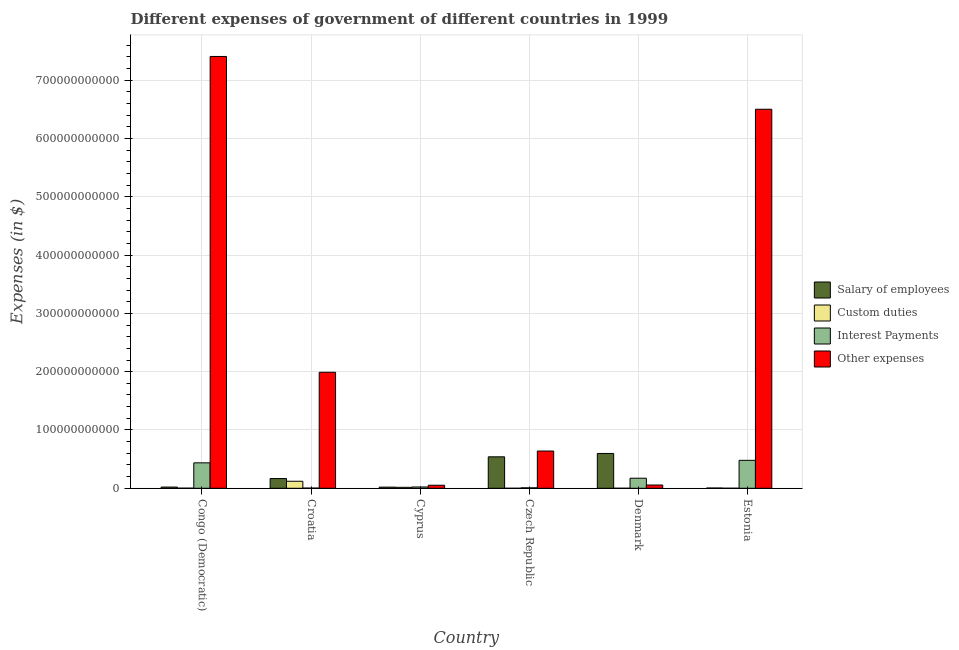How many groups of bars are there?
Your answer should be compact. 6. Are the number of bars on each tick of the X-axis equal?
Provide a short and direct response. No. How many bars are there on the 4th tick from the right?
Provide a short and direct response. 4. What is the label of the 4th group of bars from the left?
Give a very brief answer. Czech Republic. What is the amount spent on custom duties in Cyprus?
Provide a succinct answer. 1.66e+09. Across all countries, what is the maximum amount spent on interest payments?
Offer a very short reply. 4.79e+1. In which country was the amount spent on other expenses maximum?
Offer a terse response. Congo (Democratic). What is the total amount spent on salary of employees in the graph?
Provide a short and direct response. 1.35e+11. What is the difference between the amount spent on other expenses in Denmark and that in Estonia?
Your response must be concise. -6.44e+11. What is the difference between the amount spent on salary of employees in Congo (Democratic) and the amount spent on interest payments in Czech Republic?
Offer a terse response. 1.28e+09. What is the average amount spent on other expenses per country?
Ensure brevity in your answer.  2.77e+11. What is the difference between the amount spent on interest payments and amount spent on salary of employees in Denmark?
Offer a very short reply. -4.24e+1. In how many countries, is the amount spent on salary of employees greater than 300000000000 $?
Give a very brief answer. 0. What is the ratio of the amount spent on salary of employees in Denmark to that in Estonia?
Provide a succinct answer. 133.68. Is the amount spent on interest payments in Cyprus less than that in Estonia?
Offer a very short reply. Yes. Is the difference between the amount spent on custom duties in Croatia and Estonia greater than the difference between the amount spent on other expenses in Croatia and Estonia?
Give a very brief answer. Yes. What is the difference between the highest and the second highest amount spent on custom duties?
Your answer should be very brief. 1.04e+1. What is the difference between the highest and the lowest amount spent on custom duties?
Your answer should be compact. 1.20e+1. Is it the case that in every country, the sum of the amount spent on salary of employees and amount spent on custom duties is greater than the amount spent on interest payments?
Your response must be concise. No. Are all the bars in the graph horizontal?
Offer a very short reply. No. How many countries are there in the graph?
Give a very brief answer. 6. What is the difference between two consecutive major ticks on the Y-axis?
Provide a succinct answer. 1.00e+11. Are the values on the major ticks of Y-axis written in scientific E-notation?
Your response must be concise. No. Does the graph contain any zero values?
Give a very brief answer. Yes. Does the graph contain grids?
Give a very brief answer. Yes. Where does the legend appear in the graph?
Provide a succinct answer. Center right. How are the legend labels stacked?
Your answer should be very brief. Vertical. What is the title of the graph?
Offer a terse response. Different expenses of government of different countries in 1999. Does "Macroeconomic management" appear as one of the legend labels in the graph?
Keep it short and to the point. No. What is the label or title of the Y-axis?
Offer a very short reply. Expenses (in $). What is the Expenses (in $) in Salary of employees in Congo (Democratic)?
Make the answer very short. 2.08e+09. What is the Expenses (in $) in Custom duties in Congo (Democratic)?
Give a very brief answer. 1.75e+08. What is the Expenses (in $) of Interest Payments in Congo (Democratic)?
Your response must be concise. 4.36e+1. What is the Expenses (in $) of Other expenses in Congo (Democratic)?
Offer a terse response. 7.41e+11. What is the Expenses (in $) in Salary of employees in Croatia?
Your response must be concise. 1.67e+1. What is the Expenses (in $) of Custom duties in Croatia?
Give a very brief answer. 1.20e+1. What is the Expenses (in $) in Interest Payments in Croatia?
Give a very brief answer. 2.96e+08. What is the Expenses (in $) of Other expenses in Croatia?
Ensure brevity in your answer.  1.99e+11. What is the Expenses (in $) of Salary of employees in Cyprus?
Your response must be concise. 1.98e+09. What is the Expenses (in $) of Custom duties in Cyprus?
Keep it short and to the point. 1.66e+09. What is the Expenses (in $) in Interest Payments in Cyprus?
Provide a short and direct response. 2.23e+09. What is the Expenses (in $) of Other expenses in Cyprus?
Make the answer very short. 5.24e+09. What is the Expenses (in $) of Salary of employees in Czech Republic?
Your response must be concise. 5.40e+1. What is the Expenses (in $) in Custom duties in Czech Republic?
Make the answer very short. 0. What is the Expenses (in $) in Interest Payments in Czech Republic?
Give a very brief answer. 7.99e+08. What is the Expenses (in $) in Other expenses in Czech Republic?
Ensure brevity in your answer.  6.39e+1. What is the Expenses (in $) in Salary of employees in Denmark?
Your answer should be very brief. 5.97e+1. What is the Expenses (in $) in Custom duties in Denmark?
Offer a very short reply. 2.40e+07. What is the Expenses (in $) of Interest Payments in Denmark?
Your response must be concise. 1.73e+1. What is the Expenses (in $) in Other expenses in Denmark?
Give a very brief answer. 5.61e+09. What is the Expenses (in $) in Salary of employees in Estonia?
Make the answer very short. 4.47e+08. What is the Expenses (in $) in Custom duties in Estonia?
Make the answer very short. 2.60e+07. What is the Expenses (in $) in Interest Payments in Estonia?
Provide a succinct answer. 4.79e+1. What is the Expenses (in $) of Other expenses in Estonia?
Provide a short and direct response. 6.50e+11. Across all countries, what is the maximum Expenses (in $) in Salary of employees?
Your answer should be compact. 5.97e+1. Across all countries, what is the maximum Expenses (in $) in Custom duties?
Offer a very short reply. 1.20e+1. Across all countries, what is the maximum Expenses (in $) of Interest Payments?
Give a very brief answer. 4.79e+1. Across all countries, what is the maximum Expenses (in $) in Other expenses?
Provide a short and direct response. 7.41e+11. Across all countries, what is the minimum Expenses (in $) in Salary of employees?
Provide a short and direct response. 4.47e+08. Across all countries, what is the minimum Expenses (in $) in Custom duties?
Make the answer very short. 0. Across all countries, what is the minimum Expenses (in $) of Interest Payments?
Provide a succinct answer. 2.96e+08. Across all countries, what is the minimum Expenses (in $) in Other expenses?
Offer a terse response. 5.24e+09. What is the total Expenses (in $) of Salary of employees in the graph?
Ensure brevity in your answer.  1.35e+11. What is the total Expenses (in $) in Custom duties in the graph?
Give a very brief answer. 1.39e+1. What is the total Expenses (in $) in Interest Payments in the graph?
Offer a very short reply. 1.12e+11. What is the total Expenses (in $) in Other expenses in the graph?
Offer a terse response. 1.66e+12. What is the difference between the Expenses (in $) in Salary of employees in Congo (Democratic) and that in Croatia?
Your answer should be very brief. -1.46e+1. What is the difference between the Expenses (in $) of Custom duties in Congo (Democratic) and that in Croatia?
Your answer should be very brief. -1.19e+1. What is the difference between the Expenses (in $) in Interest Payments in Congo (Democratic) and that in Croatia?
Provide a short and direct response. 4.33e+1. What is the difference between the Expenses (in $) of Other expenses in Congo (Democratic) and that in Croatia?
Your answer should be very brief. 5.42e+11. What is the difference between the Expenses (in $) in Salary of employees in Congo (Democratic) and that in Cyprus?
Your answer should be very brief. 9.89e+07. What is the difference between the Expenses (in $) of Custom duties in Congo (Democratic) and that in Cyprus?
Give a very brief answer. -1.48e+09. What is the difference between the Expenses (in $) of Interest Payments in Congo (Democratic) and that in Cyprus?
Give a very brief answer. 4.14e+1. What is the difference between the Expenses (in $) in Other expenses in Congo (Democratic) and that in Cyprus?
Offer a very short reply. 7.35e+11. What is the difference between the Expenses (in $) in Salary of employees in Congo (Democratic) and that in Czech Republic?
Your answer should be very brief. -5.19e+1. What is the difference between the Expenses (in $) of Interest Payments in Congo (Democratic) and that in Czech Republic?
Your answer should be compact. 4.28e+1. What is the difference between the Expenses (in $) of Other expenses in Congo (Democratic) and that in Czech Republic?
Provide a short and direct response. 6.77e+11. What is the difference between the Expenses (in $) of Salary of employees in Congo (Democratic) and that in Denmark?
Keep it short and to the point. -5.76e+1. What is the difference between the Expenses (in $) in Custom duties in Congo (Democratic) and that in Denmark?
Your response must be concise. 1.51e+08. What is the difference between the Expenses (in $) of Interest Payments in Congo (Democratic) and that in Denmark?
Ensure brevity in your answer.  2.64e+1. What is the difference between the Expenses (in $) in Other expenses in Congo (Democratic) and that in Denmark?
Offer a very short reply. 7.35e+11. What is the difference between the Expenses (in $) in Salary of employees in Congo (Democratic) and that in Estonia?
Provide a succinct answer. 1.63e+09. What is the difference between the Expenses (in $) of Custom duties in Congo (Democratic) and that in Estonia?
Your answer should be compact. 1.49e+08. What is the difference between the Expenses (in $) in Interest Payments in Congo (Democratic) and that in Estonia?
Ensure brevity in your answer.  -4.29e+09. What is the difference between the Expenses (in $) in Other expenses in Congo (Democratic) and that in Estonia?
Offer a very short reply. 9.05e+1. What is the difference between the Expenses (in $) in Salary of employees in Croatia and that in Cyprus?
Make the answer very short. 1.47e+1. What is the difference between the Expenses (in $) in Custom duties in Croatia and that in Cyprus?
Keep it short and to the point. 1.04e+1. What is the difference between the Expenses (in $) in Interest Payments in Croatia and that in Cyprus?
Your response must be concise. -1.93e+09. What is the difference between the Expenses (in $) of Other expenses in Croatia and that in Cyprus?
Keep it short and to the point. 1.94e+11. What is the difference between the Expenses (in $) in Salary of employees in Croatia and that in Czech Republic?
Offer a terse response. -3.73e+1. What is the difference between the Expenses (in $) in Interest Payments in Croatia and that in Czech Republic?
Your answer should be compact. -5.03e+08. What is the difference between the Expenses (in $) of Other expenses in Croatia and that in Czech Republic?
Offer a terse response. 1.35e+11. What is the difference between the Expenses (in $) of Salary of employees in Croatia and that in Denmark?
Your response must be concise. -4.30e+1. What is the difference between the Expenses (in $) of Custom duties in Croatia and that in Denmark?
Provide a short and direct response. 1.20e+1. What is the difference between the Expenses (in $) in Interest Payments in Croatia and that in Denmark?
Your answer should be very brief. -1.70e+1. What is the difference between the Expenses (in $) of Other expenses in Croatia and that in Denmark?
Keep it short and to the point. 1.93e+11. What is the difference between the Expenses (in $) in Salary of employees in Croatia and that in Estonia?
Give a very brief answer. 1.62e+1. What is the difference between the Expenses (in $) in Custom duties in Croatia and that in Estonia?
Your answer should be compact. 1.20e+1. What is the difference between the Expenses (in $) of Interest Payments in Croatia and that in Estonia?
Offer a terse response. -4.76e+1. What is the difference between the Expenses (in $) in Other expenses in Croatia and that in Estonia?
Keep it short and to the point. -4.51e+11. What is the difference between the Expenses (in $) of Salary of employees in Cyprus and that in Czech Republic?
Offer a very short reply. -5.20e+1. What is the difference between the Expenses (in $) in Interest Payments in Cyprus and that in Czech Republic?
Offer a very short reply. 1.43e+09. What is the difference between the Expenses (in $) of Other expenses in Cyprus and that in Czech Republic?
Offer a terse response. -5.87e+1. What is the difference between the Expenses (in $) in Salary of employees in Cyprus and that in Denmark?
Your response must be concise. -5.77e+1. What is the difference between the Expenses (in $) in Custom duties in Cyprus and that in Denmark?
Offer a very short reply. 1.63e+09. What is the difference between the Expenses (in $) in Interest Payments in Cyprus and that in Denmark?
Ensure brevity in your answer.  -1.50e+1. What is the difference between the Expenses (in $) of Other expenses in Cyprus and that in Denmark?
Your answer should be very brief. -3.71e+08. What is the difference between the Expenses (in $) of Salary of employees in Cyprus and that in Estonia?
Provide a short and direct response. 1.53e+09. What is the difference between the Expenses (in $) of Custom duties in Cyprus and that in Estonia?
Your answer should be very brief. 1.63e+09. What is the difference between the Expenses (in $) in Interest Payments in Cyprus and that in Estonia?
Offer a terse response. -4.57e+1. What is the difference between the Expenses (in $) in Other expenses in Cyprus and that in Estonia?
Make the answer very short. -6.45e+11. What is the difference between the Expenses (in $) of Salary of employees in Czech Republic and that in Denmark?
Make the answer very short. -5.74e+09. What is the difference between the Expenses (in $) in Interest Payments in Czech Republic and that in Denmark?
Your response must be concise. -1.65e+1. What is the difference between the Expenses (in $) of Other expenses in Czech Republic and that in Denmark?
Ensure brevity in your answer.  5.83e+1. What is the difference between the Expenses (in $) in Salary of employees in Czech Republic and that in Estonia?
Ensure brevity in your answer.  5.35e+1. What is the difference between the Expenses (in $) in Interest Payments in Czech Republic and that in Estonia?
Your response must be concise. -4.71e+1. What is the difference between the Expenses (in $) of Other expenses in Czech Republic and that in Estonia?
Ensure brevity in your answer.  -5.86e+11. What is the difference between the Expenses (in $) of Salary of employees in Denmark and that in Estonia?
Ensure brevity in your answer.  5.93e+1. What is the difference between the Expenses (in $) of Custom duties in Denmark and that in Estonia?
Provide a succinct answer. -2.00e+06. What is the difference between the Expenses (in $) of Interest Payments in Denmark and that in Estonia?
Give a very brief answer. -3.06e+1. What is the difference between the Expenses (in $) of Other expenses in Denmark and that in Estonia?
Provide a succinct answer. -6.44e+11. What is the difference between the Expenses (in $) in Salary of employees in Congo (Democratic) and the Expenses (in $) in Custom duties in Croatia?
Keep it short and to the point. -9.97e+09. What is the difference between the Expenses (in $) in Salary of employees in Congo (Democratic) and the Expenses (in $) in Interest Payments in Croatia?
Make the answer very short. 1.78e+09. What is the difference between the Expenses (in $) of Salary of employees in Congo (Democratic) and the Expenses (in $) of Other expenses in Croatia?
Provide a short and direct response. -1.97e+11. What is the difference between the Expenses (in $) in Custom duties in Congo (Democratic) and the Expenses (in $) in Interest Payments in Croatia?
Offer a terse response. -1.21e+08. What is the difference between the Expenses (in $) of Custom duties in Congo (Democratic) and the Expenses (in $) of Other expenses in Croatia?
Your response must be concise. -1.99e+11. What is the difference between the Expenses (in $) of Interest Payments in Congo (Democratic) and the Expenses (in $) of Other expenses in Croatia?
Your response must be concise. -1.55e+11. What is the difference between the Expenses (in $) of Salary of employees in Congo (Democratic) and the Expenses (in $) of Custom duties in Cyprus?
Your answer should be compact. 4.25e+08. What is the difference between the Expenses (in $) of Salary of employees in Congo (Democratic) and the Expenses (in $) of Interest Payments in Cyprus?
Your response must be concise. -1.47e+08. What is the difference between the Expenses (in $) in Salary of employees in Congo (Democratic) and the Expenses (in $) in Other expenses in Cyprus?
Offer a very short reply. -3.16e+09. What is the difference between the Expenses (in $) of Custom duties in Congo (Democratic) and the Expenses (in $) of Interest Payments in Cyprus?
Offer a very short reply. -2.05e+09. What is the difference between the Expenses (in $) in Custom duties in Congo (Democratic) and the Expenses (in $) in Other expenses in Cyprus?
Your answer should be compact. -5.06e+09. What is the difference between the Expenses (in $) of Interest Payments in Congo (Democratic) and the Expenses (in $) of Other expenses in Cyprus?
Ensure brevity in your answer.  3.84e+1. What is the difference between the Expenses (in $) of Salary of employees in Congo (Democratic) and the Expenses (in $) of Interest Payments in Czech Republic?
Make the answer very short. 1.28e+09. What is the difference between the Expenses (in $) of Salary of employees in Congo (Democratic) and the Expenses (in $) of Other expenses in Czech Republic?
Your answer should be very brief. -6.18e+1. What is the difference between the Expenses (in $) of Custom duties in Congo (Democratic) and the Expenses (in $) of Interest Payments in Czech Republic?
Provide a short and direct response. -6.23e+08. What is the difference between the Expenses (in $) of Custom duties in Congo (Democratic) and the Expenses (in $) of Other expenses in Czech Republic?
Offer a very short reply. -6.37e+1. What is the difference between the Expenses (in $) in Interest Payments in Congo (Democratic) and the Expenses (in $) in Other expenses in Czech Republic?
Keep it short and to the point. -2.03e+1. What is the difference between the Expenses (in $) in Salary of employees in Congo (Democratic) and the Expenses (in $) in Custom duties in Denmark?
Ensure brevity in your answer.  2.06e+09. What is the difference between the Expenses (in $) in Salary of employees in Congo (Democratic) and the Expenses (in $) in Interest Payments in Denmark?
Offer a very short reply. -1.52e+1. What is the difference between the Expenses (in $) of Salary of employees in Congo (Democratic) and the Expenses (in $) of Other expenses in Denmark?
Make the answer very short. -3.53e+09. What is the difference between the Expenses (in $) in Custom duties in Congo (Democratic) and the Expenses (in $) in Interest Payments in Denmark?
Your response must be concise. -1.71e+1. What is the difference between the Expenses (in $) in Custom duties in Congo (Democratic) and the Expenses (in $) in Other expenses in Denmark?
Your answer should be very brief. -5.43e+09. What is the difference between the Expenses (in $) of Interest Payments in Congo (Democratic) and the Expenses (in $) of Other expenses in Denmark?
Provide a succinct answer. 3.80e+1. What is the difference between the Expenses (in $) in Salary of employees in Congo (Democratic) and the Expenses (in $) in Custom duties in Estonia?
Your answer should be very brief. 2.05e+09. What is the difference between the Expenses (in $) in Salary of employees in Congo (Democratic) and the Expenses (in $) in Interest Payments in Estonia?
Your answer should be compact. -4.58e+1. What is the difference between the Expenses (in $) in Salary of employees in Congo (Democratic) and the Expenses (in $) in Other expenses in Estonia?
Provide a short and direct response. -6.48e+11. What is the difference between the Expenses (in $) in Custom duties in Congo (Democratic) and the Expenses (in $) in Interest Payments in Estonia?
Offer a very short reply. -4.77e+1. What is the difference between the Expenses (in $) in Custom duties in Congo (Democratic) and the Expenses (in $) in Other expenses in Estonia?
Your answer should be compact. -6.50e+11. What is the difference between the Expenses (in $) of Interest Payments in Congo (Democratic) and the Expenses (in $) of Other expenses in Estonia?
Keep it short and to the point. -6.06e+11. What is the difference between the Expenses (in $) in Salary of employees in Croatia and the Expenses (in $) in Custom duties in Cyprus?
Give a very brief answer. 1.50e+1. What is the difference between the Expenses (in $) of Salary of employees in Croatia and the Expenses (in $) of Interest Payments in Cyprus?
Make the answer very short. 1.45e+1. What is the difference between the Expenses (in $) of Salary of employees in Croatia and the Expenses (in $) of Other expenses in Cyprus?
Your response must be concise. 1.14e+1. What is the difference between the Expenses (in $) in Custom duties in Croatia and the Expenses (in $) in Interest Payments in Cyprus?
Ensure brevity in your answer.  9.82e+09. What is the difference between the Expenses (in $) in Custom duties in Croatia and the Expenses (in $) in Other expenses in Cyprus?
Keep it short and to the point. 6.81e+09. What is the difference between the Expenses (in $) in Interest Payments in Croatia and the Expenses (in $) in Other expenses in Cyprus?
Your answer should be very brief. -4.94e+09. What is the difference between the Expenses (in $) in Salary of employees in Croatia and the Expenses (in $) in Interest Payments in Czech Republic?
Provide a succinct answer. 1.59e+1. What is the difference between the Expenses (in $) of Salary of employees in Croatia and the Expenses (in $) of Other expenses in Czech Republic?
Provide a succinct answer. -4.72e+1. What is the difference between the Expenses (in $) of Custom duties in Croatia and the Expenses (in $) of Interest Payments in Czech Republic?
Keep it short and to the point. 1.13e+1. What is the difference between the Expenses (in $) in Custom duties in Croatia and the Expenses (in $) in Other expenses in Czech Republic?
Offer a terse response. -5.18e+1. What is the difference between the Expenses (in $) of Interest Payments in Croatia and the Expenses (in $) of Other expenses in Czech Republic?
Offer a terse response. -6.36e+1. What is the difference between the Expenses (in $) in Salary of employees in Croatia and the Expenses (in $) in Custom duties in Denmark?
Give a very brief answer. 1.67e+1. What is the difference between the Expenses (in $) in Salary of employees in Croatia and the Expenses (in $) in Interest Payments in Denmark?
Ensure brevity in your answer.  -5.86e+08. What is the difference between the Expenses (in $) in Salary of employees in Croatia and the Expenses (in $) in Other expenses in Denmark?
Make the answer very short. 1.11e+1. What is the difference between the Expenses (in $) in Custom duties in Croatia and the Expenses (in $) in Interest Payments in Denmark?
Provide a succinct answer. -5.22e+09. What is the difference between the Expenses (in $) of Custom duties in Croatia and the Expenses (in $) of Other expenses in Denmark?
Keep it short and to the point. 6.44e+09. What is the difference between the Expenses (in $) in Interest Payments in Croatia and the Expenses (in $) in Other expenses in Denmark?
Provide a succinct answer. -5.31e+09. What is the difference between the Expenses (in $) of Salary of employees in Croatia and the Expenses (in $) of Custom duties in Estonia?
Keep it short and to the point. 1.67e+1. What is the difference between the Expenses (in $) in Salary of employees in Croatia and the Expenses (in $) in Interest Payments in Estonia?
Make the answer very short. -3.12e+1. What is the difference between the Expenses (in $) of Salary of employees in Croatia and the Expenses (in $) of Other expenses in Estonia?
Ensure brevity in your answer.  -6.33e+11. What is the difference between the Expenses (in $) of Custom duties in Croatia and the Expenses (in $) of Interest Payments in Estonia?
Give a very brief answer. -3.59e+1. What is the difference between the Expenses (in $) of Custom duties in Croatia and the Expenses (in $) of Other expenses in Estonia?
Your answer should be very brief. -6.38e+11. What is the difference between the Expenses (in $) of Interest Payments in Croatia and the Expenses (in $) of Other expenses in Estonia?
Give a very brief answer. -6.50e+11. What is the difference between the Expenses (in $) of Salary of employees in Cyprus and the Expenses (in $) of Interest Payments in Czech Republic?
Your answer should be compact. 1.18e+09. What is the difference between the Expenses (in $) in Salary of employees in Cyprus and the Expenses (in $) in Other expenses in Czech Republic?
Provide a short and direct response. -6.19e+1. What is the difference between the Expenses (in $) of Custom duties in Cyprus and the Expenses (in $) of Interest Payments in Czech Republic?
Your answer should be very brief. 8.57e+08. What is the difference between the Expenses (in $) of Custom duties in Cyprus and the Expenses (in $) of Other expenses in Czech Republic?
Provide a succinct answer. -6.22e+1. What is the difference between the Expenses (in $) of Interest Payments in Cyprus and the Expenses (in $) of Other expenses in Czech Republic?
Your response must be concise. -6.17e+1. What is the difference between the Expenses (in $) in Salary of employees in Cyprus and the Expenses (in $) in Custom duties in Denmark?
Ensure brevity in your answer.  1.96e+09. What is the difference between the Expenses (in $) of Salary of employees in Cyprus and the Expenses (in $) of Interest Payments in Denmark?
Provide a short and direct response. -1.53e+1. What is the difference between the Expenses (in $) of Salary of employees in Cyprus and the Expenses (in $) of Other expenses in Denmark?
Your answer should be very brief. -3.63e+09. What is the difference between the Expenses (in $) in Custom duties in Cyprus and the Expenses (in $) in Interest Payments in Denmark?
Keep it short and to the point. -1.56e+1. What is the difference between the Expenses (in $) of Custom duties in Cyprus and the Expenses (in $) of Other expenses in Denmark?
Give a very brief answer. -3.95e+09. What is the difference between the Expenses (in $) in Interest Payments in Cyprus and the Expenses (in $) in Other expenses in Denmark?
Provide a short and direct response. -3.38e+09. What is the difference between the Expenses (in $) in Salary of employees in Cyprus and the Expenses (in $) in Custom duties in Estonia?
Offer a very short reply. 1.96e+09. What is the difference between the Expenses (in $) of Salary of employees in Cyprus and the Expenses (in $) of Interest Payments in Estonia?
Your answer should be very brief. -4.59e+1. What is the difference between the Expenses (in $) of Salary of employees in Cyprus and the Expenses (in $) of Other expenses in Estonia?
Make the answer very short. -6.48e+11. What is the difference between the Expenses (in $) of Custom duties in Cyprus and the Expenses (in $) of Interest Payments in Estonia?
Your answer should be compact. -4.63e+1. What is the difference between the Expenses (in $) of Custom duties in Cyprus and the Expenses (in $) of Other expenses in Estonia?
Your answer should be very brief. -6.48e+11. What is the difference between the Expenses (in $) of Interest Payments in Cyprus and the Expenses (in $) of Other expenses in Estonia?
Offer a terse response. -6.48e+11. What is the difference between the Expenses (in $) of Salary of employees in Czech Republic and the Expenses (in $) of Custom duties in Denmark?
Offer a terse response. 5.39e+1. What is the difference between the Expenses (in $) in Salary of employees in Czech Republic and the Expenses (in $) in Interest Payments in Denmark?
Provide a succinct answer. 3.67e+1. What is the difference between the Expenses (in $) of Salary of employees in Czech Republic and the Expenses (in $) of Other expenses in Denmark?
Provide a short and direct response. 4.84e+1. What is the difference between the Expenses (in $) in Interest Payments in Czech Republic and the Expenses (in $) in Other expenses in Denmark?
Offer a very short reply. -4.81e+09. What is the difference between the Expenses (in $) of Salary of employees in Czech Republic and the Expenses (in $) of Custom duties in Estonia?
Keep it short and to the point. 5.39e+1. What is the difference between the Expenses (in $) in Salary of employees in Czech Republic and the Expenses (in $) in Interest Payments in Estonia?
Ensure brevity in your answer.  6.05e+09. What is the difference between the Expenses (in $) in Salary of employees in Czech Republic and the Expenses (in $) in Other expenses in Estonia?
Make the answer very short. -5.96e+11. What is the difference between the Expenses (in $) of Interest Payments in Czech Republic and the Expenses (in $) of Other expenses in Estonia?
Provide a short and direct response. -6.49e+11. What is the difference between the Expenses (in $) in Salary of employees in Denmark and the Expenses (in $) in Custom duties in Estonia?
Your answer should be compact. 5.97e+1. What is the difference between the Expenses (in $) of Salary of employees in Denmark and the Expenses (in $) of Interest Payments in Estonia?
Offer a terse response. 1.18e+1. What is the difference between the Expenses (in $) in Salary of employees in Denmark and the Expenses (in $) in Other expenses in Estonia?
Keep it short and to the point. -5.90e+11. What is the difference between the Expenses (in $) in Custom duties in Denmark and the Expenses (in $) in Interest Payments in Estonia?
Keep it short and to the point. -4.79e+1. What is the difference between the Expenses (in $) of Custom duties in Denmark and the Expenses (in $) of Other expenses in Estonia?
Ensure brevity in your answer.  -6.50e+11. What is the difference between the Expenses (in $) of Interest Payments in Denmark and the Expenses (in $) of Other expenses in Estonia?
Provide a short and direct response. -6.33e+11. What is the average Expenses (in $) of Salary of employees per country?
Make the answer very short. 2.25e+1. What is the average Expenses (in $) in Custom duties per country?
Ensure brevity in your answer.  2.32e+09. What is the average Expenses (in $) in Interest Payments per country?
Give a very brief answer. 1.87e+1. What is the average Expenses (in $) of Other expenses per country?
Your answer should be very brief. 2.77e+11. What is the difference between the Expenses (in $) in Salary of employees and Expenses (in $) in Custom duties in Congo (Democratic)?
Your answer should be compact. 1.90e+09. What is the difference between the Expenses (in $) of Salary of employees and Expenses (in $) of Interest Payments in Congo (Democratic)?
Your answer should be very brief. -4.16e+1. What is the difference between the Expenses (in $) of Salary of employees and Expenses (in $) of Other expenses in Congo (Democratic)?
Your answer should be compact. -7.39e+11. What is the difference between the Expenses (in $) in Custom duties and Expenses (in $) in Interest Payments in Congo (Democratic)?
Your response must be concise. -4.35e+1. What is the difference between the Expenses (in $) of Custom duties and Expenses (in $) of Other expenses in Congo (Democratic)?
Your answer should be very brief. -7.40e+11. What is the difference between the Expenses (in $) in Interest Payments and Expenses (in $) in Other expenses in Congo (Democratic)?
Give a very brief answer. -6.97e+11. What is the difference between the Expenses (in $) of Salary of employees and Expenses (in $) of Custom duties in Croatia?
Your answer should be compact. 4.64e+09. What is the difference between the Expenses (in $) of Salary of employees and Expenses (in $) of Interest Payments in Croatia?
Ensure brevity in your answer.  1.64e+1. What is the difference between the Expenses (in $) in Salary of employees and Expenses (in $) in Other expenses in Croatia?
Keep it short and to the point. -1.82e+11. What is the difference between the Expenses (in $) of Custom duties and Expenses (in $) of Interest Payments in Croatia?
Provide a short and direct response. 1.18e+1. What is the difference between the Expenses (in $) of Custom duties and Expenses (in $) of Other expenses in Croatia?
Your response must be concise. -1.87e+11. What is the difference between the Expenses (in $) of Interest Payments and Expenses (in $) of Other expenses in Croatia?
Provide a short and direct response. -1.99e+11. What is the difference between the Expenses (in $) of Salary of employees and Expenses (in $) of Custom duties in Cyprus?
Offer a very short reply. 3.26e+08. What is the difference between the Expenses (in $) in Salary of employees and Expenses (in $) in Interest Payments in Cyprus?
Your answer should be very brief. -2.46e+08. What is the difference between the Expenses (in $) of Salary of employees and Expenses (in $) of Other expenses in Cyprus?
Offer a terse response. -3.26e+09. What is the difference between the Expenses (in $) of Custom duties and Expenses (in $) of Interest Payments in Cyprus?
Offer a terse response. -5.72e+08. What is the difference between the Expenses (in $) in Custom duties and Expenses (in $) in Other expenses in Cyprus?
Your answer should be very brief. -3.58e+09. What is the difference between the Expenses (in $) in Interest Payments and Expenses (in $) in Other expenses in Cyprus?
Keep it short and to the point. -3.01e+09. What is the difference between the Expenses (in $) of Salary of employees and Expenses (in $) of Interest Payments in Czech Republic?
Keep it short and to the point. 5.32e+1. What is the difference between the Expenses (in $) of Salary of employees and Expenses (in $) of Other expenses in Czech Republic?
Offer a very short reply. -9.92e+09. What is the difference between the Expenses (in $) in Interest Payments and Expenses (in $) in Other expenses in Czech Republic?
Offer a terse response. -6.31e+1. What is the difference between the Expenses (in $) of Salary of employees and Expenses (in $) of Custom duties in Denmark?
Keep it short and to the point. 5.97e+1. What is the difference between the Expenses (in $) in Salary of employees and Expenses (in $) in Interest Payments in Denmark?
Ensure brevity in your answer.  4.24e+1. What is the difference between the Expenses (in $) of Salary of employees and Expenses (in $) of Other expenses in Denmark?
Provide a succinct answer. 5.41e+1. What is the difference between the Expenses (in $) in Custom duties and Expenses (in $) in Interest Payments in Denmark?
Provide a succinct answer. -1.72e+1. What is the difference between the Expenses (in $) of Custom duties and Expenses (in $) of Other expenses in Denmark?
Offer a terse response. -5.58e+09. What is the difference between the Expenses (in $) of Interest Payments and Expenses (in $) of Other expenses in Denmark?
Your response must be concise. 1.17e+1. What is the difference between the Expenses (in $) in Salary of employees and Expenses (in $) in Custom duties in Estonia?
Ensure brevity in your answer.  4.21e+08. What is the difference between the Expenses (in $) of Salary of employees and Expenses (in $) of Interest Payments in Estonia?
Ensure brevity in your answer.  -4.75e+1. What is the difference between the Expenses (in $) of Salary of employees and Expenses (in $) of Other expenses in Estonia?
Provide a succinct answer. -6.50e+11. What is the difference between the Expenses (in $) in Custom duties and Expenses (in $) in Interest Payments in Estonia?
Offer a very short reply. -4.79e+1. What is the difference between the Expenses (in $) of Custom duties and Expenses (in $) of Other expenses in Estonia?
Your answer should be very brief. -6.50e+11. What is the difference between the Expenses (in $) in Interest Payments and Expenses (in $) in Other expenses in Estonia?
Make the answer very short. -6.02e+11. What is the ratio of the Expenses (in $) of Salary of employees in Congo (Democratic) to that in Croatia?
Your answer should be compact. 0.12. What is the ratio of the Expenses (in $) of Custom duties in Congo (Democratic) to that in Croatia?
Provide a succinct answer. 0.01. What is the ratio of the Expenses (in $) of Interest Payments in Congo (Democratic) to that in Croatia?
Your answer should be very brief. 147.41. What is the ratio of the Expenses (in $) in Other expenses in Congo (Democratic) to that in Croatia?
Give a very brief answer. 3.72. What is the ratio of the Expenses (in $) of Salary of employees in Congo (Democratic) to that in Cyprus?
Ensure brevity in your answer.  1.05. What is the ratio of the Expenses (in $) in Custom duties in Congo (Democratic) to that in Cyprus?
Ensure brevity in your answer.  0.11. What is the ratio of the Expenses (in $) of Interest Payments in Congo (Democratic) to that in Cyprus?
Your answer should be compact. 19.59. What is the ratio of the Expenses (in $) of Other expenses in Congo (Democratic) to that in Cyprus?
Offer a terse response. 141.42. What is the ratio of the Expenses (in $) in Salary of employees in Congo (Democratic) to that in Czech Republic?
Make the answer very short. 0.04. What is the ratio of the Expenses (in $) of Interest Payments in Congo (Democratic) to that in Czech Republic?
Ensure brevity in your answer.  54.62. What is the ratio of the Expenses (in $) of Other expenses in Congo (Democratic) to that in Czech Republic?
Provide a succinct answer. 11.59. What is the ratio of the Expenses (in $) of Salary of employees in Congo (Democratic) to that in Denmark?
Your answer should be compact. 0.03. What is the ratio of the Expenses (in $) of Custom duties in Congo (Democratic) to that in Denmark?
Your answer should be compact. 7.31. What is the ratio of the Expenses (in $) of Interest Payments in Congo (Democratic) to that in Denmark?
Your response must be concise. 2.53. What is the ratio of the Expenses (in $) in Other expenses in Congo (Democratic) to that in Denmark?
Make the answer very short. 132.07. What is the ratio of the Expenses (in $) of Salary of employees in Congo (Democratic) to that in Estonia?
Make the answer very short. 4.66. What is the ratio of the Expenses (in $) in Custom duties in Congo (Democratic) to that in Estonia?
Your answer should be very brief. 6.75. What is the ratio of the Expenses (in $) of Interest Payments in Congo (Democratic) to that in Estonia?
Your answer should be very brief. 0.91. What is the ratio of the Expenses (in $) of Other expenses in Congo (Democratic) to that in Estonia?
Your answer should be compact. 1.14. What is the ratio of the Expenses (in $) in Salary of employees in Croatia to that in Cyprus?
Keep it short and to the point. 8.42. What is the ratio of the Expenses (in $) of Custom duties in Croatia to that in Cyprus?
Give a very brief answer. 7.28. What is the ratio of the Expenses (in $) of Interest Payments in Croatia to that in Cyprus?
Offer a terse response. 0.13. What is the ratio of the Expenses (in $) of Other expenses in Croatia to that in Cyprus?
Your answer should be compact. 37.99. What is the ratio of the Expenses (in $) in Salary of employees in Croatia to that in Czech Republic?
Your response must be concise. 0.31. What is the ratio of the Expenses (in $) of Interest Payments in Croatia to that in Czech Republic?
Your response must be concise. 0.37. What is the ratio of the Expenses (in $) in Other expenses in Croatia to that in Czech Republic?
Offer a very short reply. 3.11. What is the ratio of the Expenses (in $) in Salary of employees in Croatia to that in Denmark?
Your response must be concise. 0.28. What is the ratio of the Expenses (in $) of Custom duties in Croatia to that in Denmark?
Keep it short and to the point. 502.08. What is the ratio of the Expenses (in $) of Interest Payments in Croatia to that in Denmark?
Make the answer very short. 0.02. What is the ratio of the Expenses (in $) in Other expenses in Croatia to that in Denmark?
Ensure brevity in your answer.  35.48. What is the ratio of the Expenses (in $) in Salary of employees in Croatia to that in Estonia?
Provide a succinct answer. 37.35. What is the ratio of the Expenses (in $) in Custom duties in Croatia to that in Estonia?
Ensure brevity in your answer.  463.46. What is the ratio of the Expenses (in $) in Interest Payments in Croatia to that in Estonia?
Keep it short and to the point. 0.01. What is the ratio of the Expenses (in $) of Other expenses in Croatia to that in Estonia?
Keep it short and to the point. 0.31. What is the ratio of the Expenses (in $) of Salary of employees in Cyprus to that in Czech Republic?
Provide a short and direct response. 0.04. What is the ratio of the Expenses (in $) in Interest Payments in Cyprus to that in Czech Republic?
Offer a terse response. 2.79. What is the ratio of the Expenses (in $) of Other expenses in Cyprus to that in Czech Republic?
Keep it short and to the point. 0.08. What is the ratio of the Expenses (in $) of Salary of employees in Cyprus to that in Denmark?
Offer a terse response. 0.03. What is the ratio of the Expenses (in $) in Custom duties in Cyprus to that in Denmark?
Keep it short and to the point. 68.97. What is the ratio of the Expenses (in $) of Interest Payments in Cyprus to that in Denmark?
Your response must be concise. 0.13. What is the ratio of the Expenses (in $) of Other expenses in Cyprus to that in Denmark?
Make the answer very short. 0.93. What is the ratio of the Expenses (in $) in Salary of employees in Cyprus to that in Estonia?
Provide a succinct answer. 4.43. What is the ratio of the Expenses (in $) in Custom duties in Cyprus to that in Estonia?
Your answer should be compact. 63.67. What is the ratio of the Expenses (in $) in Interest Payments in Cyprus to that in Estonia?
Ensure brevity in your answer.  0.05. What is the ratio of the Expenses (in $) of Other expenses in Cyprus to that in Estonia?
Give a very brief answer. 0.01. What is the ratio of the Expenses (in $) of Salary of employees in Czech Republic to that in Denmark?
Provide a succinct answer. 0.9. What is the ratio of the Expenses (in $) of Interest Payments in Czech Republic to that in Denmark?
Offer a very short reply. 0.05. What is the ratio of the Expenses (in $) in Other expenses in Czech Republic to that in Denmark?
Your answer should be very brief. 11.39. What is the ratio of the Expenses (in $) of Salary of employees in Czech Republic to that in Estonia?
Offer a terse response. 120.82. What is the ratio of the Expenses (in $) in Interest Payments in Czech Republic to that in Estonia?
Offer a very short reply. 0.02. What is the ratio of the Expenses (in $) in Other expenses in Czech Republic to that in Estonia?
Offer a very short reply. 0.1. What is the ratio of the Expenses (in $) of Salary of employees in Denmark to that in Estonia?
Ensure brevity in your answer.  133.68. What is the ratio of the Expenses (in $) of Custom duties in Denmark to that in Estonia?
Make the answer very short. 0.92. What is the ratio of the Expenses (in $) in Interest Payments in Denmark to that in Estonia?
Offer a very short reply. 0.36. What is the ratio of the Expenses (in $) of Other expenses in Denmark to that in Estonia?
Give a very brief answer. 0.01. What is the difference between the highest and the second highest Expenses (in $) in Salary of employees?
Your answer should be compact. 5.74e+09. What is the difference between the highest and the second highest Expenses (in $) of Custom duties?
Make the answer very short. 1.04e+1. What is the difference between the highest and the second highest Expenses (in $) in Interest Payments?
Provide a succinct answer. 4.29e+09. What is the difference between the highest and the second highest Expenses (in $) of Other expenses?
Ensure brevity in your answer.  9.05e+1. What is the difference between the highest and the lowest Expenses (in $) of Salary of employees?
Provide a short and direct response. 5.93e+1. What is the difference between the highest and the lowest Expenses (in $) in Custom duties?
Give a very brief answer. 1.20e+1. What is the difference between the highest and the lowest Expenses (in $) of Interest Payments?
Your answer should be compact. 4.76e+1. What is the difference between the highest and the lowest Expenses (in $) in Other expenses?
Your response must be concise. 7.35e+11. 